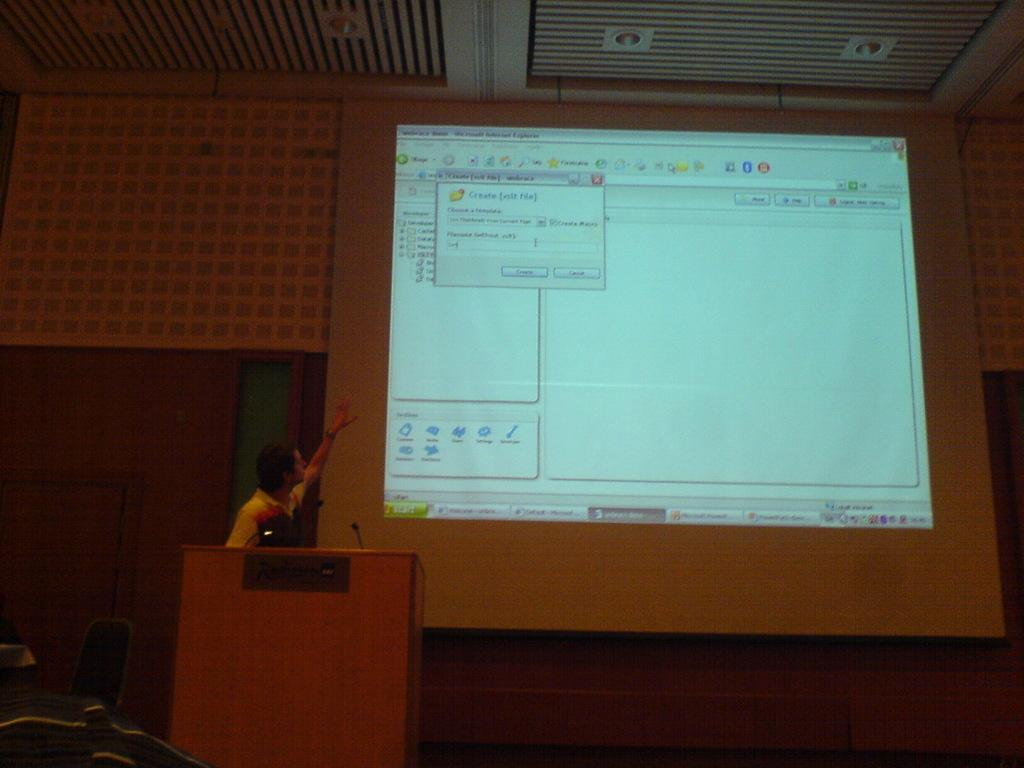<image>
Provide a brief description of the given image. A man stands in front of a projector screen with a create xsit file window open on it. 